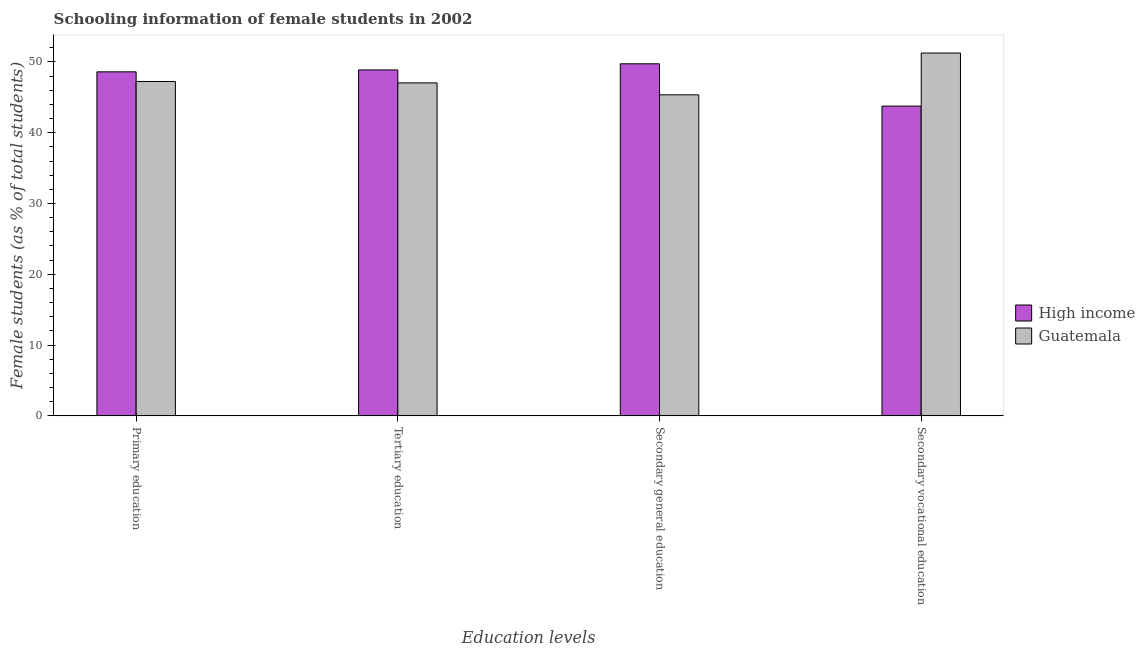How many groups of bars are there?
Ensure brevity in your answer.  4. Are the number of bars per tick equal to the number of legend labels?
Your answer should be very brief. Yes. Are the number of bars on each tick of the X-axis equal?
Keep it short and to the point. Yes. How many bars are there on the 2nd tick from the right?
Provide a short and direct response. 2. What is the label of the 2nd group of bars from the left?
Provide a short and direct response. Tertiary education. What is the percentage of female students in tertiary education in High income?
Your response must be concise. 48.87. Across all countries, what is the maximum percentage of female students in tertiary education?
Provide a short and direct response. 48.87. Across all countries, what is the minimum percentage of female students in secondary vocational education?
Provide a short and direct response. 43.76. In which country was the percentage of female students in tertiary education maximum?
Your answer should be compact. High income. In which country was the percentage of female students in tertiary education minimum?
Provide a succinct answer. Guatemala. What is the total percentage of female students in secondary vocational education in the graph?
Provide a succinct answer. 95.02. What is the difference between the percentage of female students in tertiary education in High income and that in Guatemala?
Give a very brief answer. 1.83. What is the difference between the percentage of female students in primary education in High income and the percentage of female students in tertiary education in Guatemala?
Provide a short and direct response. 1.56. What is the average percentage of female students in secondary education per country?
Offer a very short reply. 47.55. What is the difference between the percentage of female students in primary education and percentage of female students in secondary education in Guatemala?
Provide a succinct answer. 1.89. What is the ratio of the percentage of female students in secondary education in Guatemala to that in High income?
Make the answer very short. 0.91. Is the percentage of female students in secondary vocational education in Guatemala less than that in High income?
Your response must be concise. No. What is the difference between the highest and the second highest percentage of female students in tertiary education?
Provide a short and direct response. 1.83. What is the difference between the highest and the lowest percentage of female students in secondary vocational education?
Make the answer very short. 7.5. Is the sum of the percentage of female students in tertiary education in High income and Guatemala greater than the maximum percentage of female students in secondary vocational education across all countries?
Offer a terse response. Yes. What does the 1st bar from the right in Secondary general education represents?
Make the answer very short. Guatemala. Are all the bars in the graph horizontal?
Your answer should be very brief. No. How many countries are there in the graph?
Your answer should be very brief. 2. Are the values on the major ticks of Y-axis written in scientific E-notation?
Your answer should be very brief. No. Does the graph contain any zero values?
Your answer should be very brief. No. Does the graph contain grids?
Offer a very short reply. No. How many legend labels are there?
Make the answer very short. 2. What is the title of the graph?
Offer a terse response. Schooling information of female students in 2002. Does "Belgium" appear as one of the legend labels in the graph?
Make the answer very short. No. What is the label or title of the X-axis?
Ensure brevity in your answer.  Education levels. What is the label or title of the Y-axis?
Keep it short and to the point. Female students (as % of total students). What is the Female students (as % of total students) in High income in Primary education?
Your answer should be very brief. 48.6. What is the Female students (as % of total students) in Guatemala in Primary education?
Your response must be concise. 47.24. What is the Female students (as % of total students) of High income in Tertiary education?
Keep it short and to the point. 48.87. What is the Female students (as % of total students) in Guatemala in Tertiary education?
Your answer should be very brief. 47.04. What is the Female students (as % of total students) of High income in Secondary general education?
Ensure brevity in your answer.  49.74. What is the Female students (as % of total students) of Guatemala in Secondary general education?
Your answer should be very brief. 45.36. What is the Female students (as % of total students) in High income in Secondary vocational education?
Ensure brevity in your answer.  43.76. What is the Female students (as % of total students) of Guatemala in Secondary vocational education?
Your answer should be very brief. 51.26. Across all Education levels, what is the maximum Female students (as % of total students) in High income?
Your response must be concise. 49.74. Across all Education levels, what is the maximum Female students (as % of total students) of Guatemala?
Keep it short and to the point. 51.26. Across all Education levels, what is the minimum Female students (as % of total students) of High income?
Your response must be concise. 43.76. Across all Education levels, what is the minimum Female students (as % of total students) in Guatemala?
Provide a short and direct response. 45.36. What is the total Female students (as % of total students) of High income in the graph?
Ensure brevity in your answer.  190.97. What is the total Female students (as % of total students) in Guatemala in the graph?
Give a very brief answer. 190.9. What is the difference between the Female students (as % of total students) of High income in Primary education and that in Tertiary education?
Provide a succinct answer. -0.27. What is the difference between the Female students (as % of total students) of Guatemala in Primary education and that in Tertiary education?
Provide a succinct answer. 0.2. What is the difference between the Female students (as % of total students) in High income in Primary education and that in Secondary general education?
Your response must be concise. -1.14. What is the difference between the Female students (as % of total students) in Guatemala in Primary education and that in Secondary general education?
Keep it short and to the point. 1.89. What is the difference between the Female students (as % of total students) in High income in Primary education and that in Secondary vocational education?
Your response must be concise. 4.84. What is the difference between the Female students (as % of total students) in Guatemala in Primary education and that in Secondary vocational education?
Provide a succinct answer. -4.02. What is the difference between the Female students (as % of total students) in High income in Tertiary education and that in Secondary general education?
Your answer should be very brief. -0.87. What is the difference between the Female students (as % of total students) of Guatemala in Tertiary education and that in Secondary general education?
Keep it short and to the point. 1.68. What is the difference between the Female students (as % of total students) in High income in Tertiary education and that in Secondary vocational education?
Offer a very short reply. 5.11. What is the difference between the Female students (as % of total students) in Guatemala in Tertiary education and that in Secondary vocational education?
Provide a short and direct response. -4.22. What is the difference between the Female students (as % of total students) of High income in Secondary general education and that in Secondary vocational education?
Offer a terse response. 5.98. What is the difference between the Female students (as % of total students) of Guatemala in Secondary general education and that in Secondary vocational education?
Your answer should be compact. -5.9. What is the difference between the Female students (as % of total students) of High income in Primary education and the Female students (as % of total students) of Guatemala in Tertiary education?
Your answer should be compact. 1.56. What is the difference between the Female students (as % of total students) in High income in Primary education and the Female students (as % of total students) in Guatemala in Secondary general education?
Your answer should be very brief. 3.25. What is the difference between the Female students (as % of total students) of High income in Primary education and the Female students (as % of total students) of Guatemala in Secondary vocational education?
Offer a terse response. -2.66. What is the difference between the Female students (as % of total students) of High income in Tertiary education and the Female students (as % of total students) of Guatemala in Secondary general education?
Provide a short and direct response. 3.51. What is the difference between the Female students (as % of total students) in High income in Tertiary education and the Female students (as % of total students) in Guatemala in Secondary vocational education?
Make the answer very short. -2.39. What is the difference between the Female students (as % of total students) in High income in Secondary general education and the Female students (as % of total students) in Guatemala in Secondary vocational education?
Keep it short and to the point. -1.52. What is the average Female students (as % of total students) of High income per Education levels?
Your answer should be very brief. 47.74. What is the average Female students (as % of total students) of Guatemala per Education levels?
Give a very brief answer. 47.72. What is the difference between the Female students (as % of total students) of High income and Female students (as % of total students) of Guatemala in Primary education?
Your response must be concise. 1.36. What is the difference between the Female students (as % of total students) in High income and Female students (as % of total students) in Guatemala in Tertiary education?
Your answer should be compact. 1.83. What is the difference between the Female students (as % of total students) in High income and Female students (as % of total students) in Guatemala in Secondary general education?
Keep it short and to the point. 4.38. What is the difference between the Female students (as % of total students) in High income and Female students (as % of total students) in Guatemala in Secondary vocational education?
Make the answer very short. -7.5. What is the ratio of the Female students (as % of total students) in High income in Primary education to that in Tertiary education?
Make the answer very short. 0.99. What is the ratio of the Female students (as % of total students) of Guatemala in Primary education to that in Tertiary education?
Your answer should be compact. 1. What is the ratio of the Female students (as % of total students) of High income in Primary education to that in Secondary general education?
Provide a succinct answer. 0.98. What is the ratio of the Female students (as % of total students) in Guatemala in Primary education to that in Secondary general education?
Provide a succinct answer. 1.04. What is the ratio of the Female students (as % of total students) in High income in Primary education to that in Secondary vocational education?
Give a very brief answer. 1.11. What is the ratio of the Female students (as % of total students) in Guatemala in Primary education to that in Secondary vocational education?
Keep it short and to the point. 0.92. What is the ratio of the Female students (as % of total students) in High income in Tertiary education to that in Secondary general education?
Give a very brief answer. 0.98. What is the ratio of the Female students (as % of total students) of Guatemala in Tertiary education to that in Secondary general education?
Give a very brief answer. 1.04. What is the ratio of the Female students (as % of total students) of High income in Tertiary education to that in Secondary vocational education?
Provide a short and direct response. 1.12. What is the ratio of the Female students (as % of total students) of Guatemala in Tertiary education to that in Secondary vocational education?
Your answer should be compact. 0.92. What is the ratio of the Female students (as % of total students) of High income in Secondary general education to that in Secondary vocational education?
Offer a very short reply. 1.14. What is the ratio of the Female students (as % of total students) of Guatemala in Secondary general education to that in Secondary vocational education?
Your response must be concise. 0.88. What is the difference between the highest and the second highest Female students (as % of total students) in High income?
Ensure brevity in your answer.  0.87. What is the difference between the highest and the second highest Female students (as % of total students) in Guatemala?
Your answer should be compact. 4.02. What is the difference between the highest and the lowest Female students (as % of total students) in High income?
Offer a very short reply. 5.98. What is the difference between the highest and the lowest Female students (as % of total students) of Guatemala?
Provide a short and direct response. 5.9. 